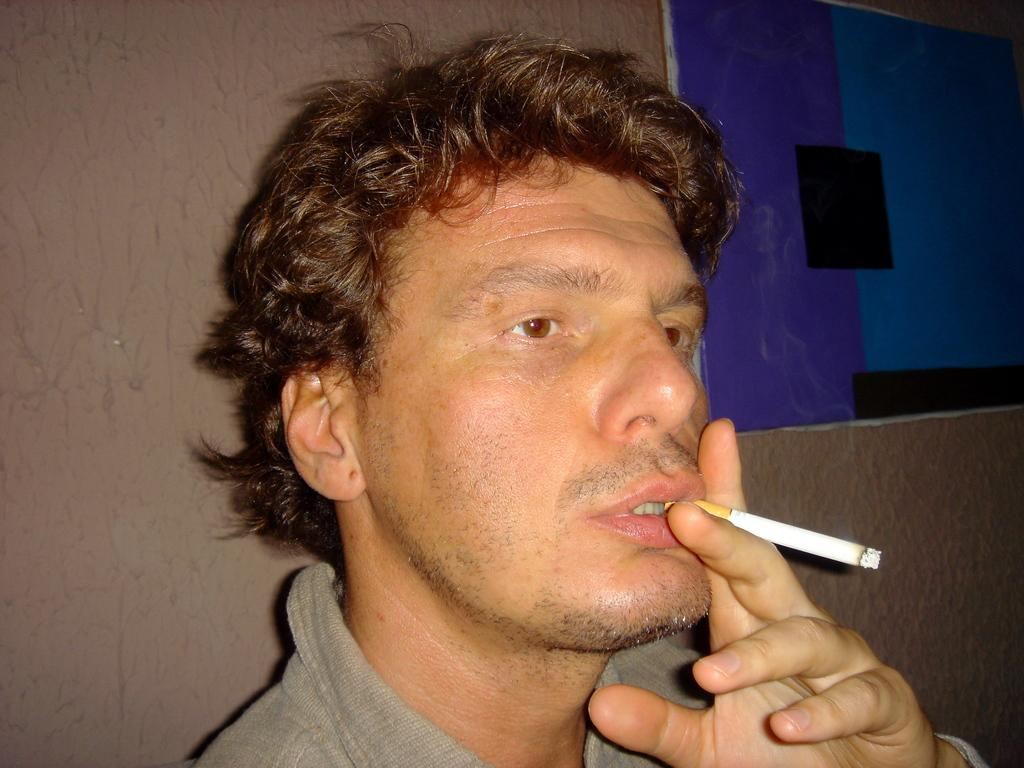Who is present in the image? There is a man in the image. What is the man wearing? The man is wearing a shirt. What is the man holding in the image? The man is holding a cigarette. Where is the man standing in the image? The man is standing near a wall. What can be seen in the top right corner of the image? There is a poster in the top right corner of the image. What arithmetic problem is the man trying to solve in the image? There is no arithmetic problem visible in the image. What type of crack is present on the wall near the man? There is no crack visible on the wall near the man in the image. 